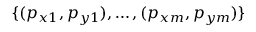<formula> <loc_0><loc_0><loc_500><loc_500>\{ ( p _ { x 1 } , p _ { y 1 } ) , \dots , ( p _ { x m } , p _ { y m } ) \}</formula> 